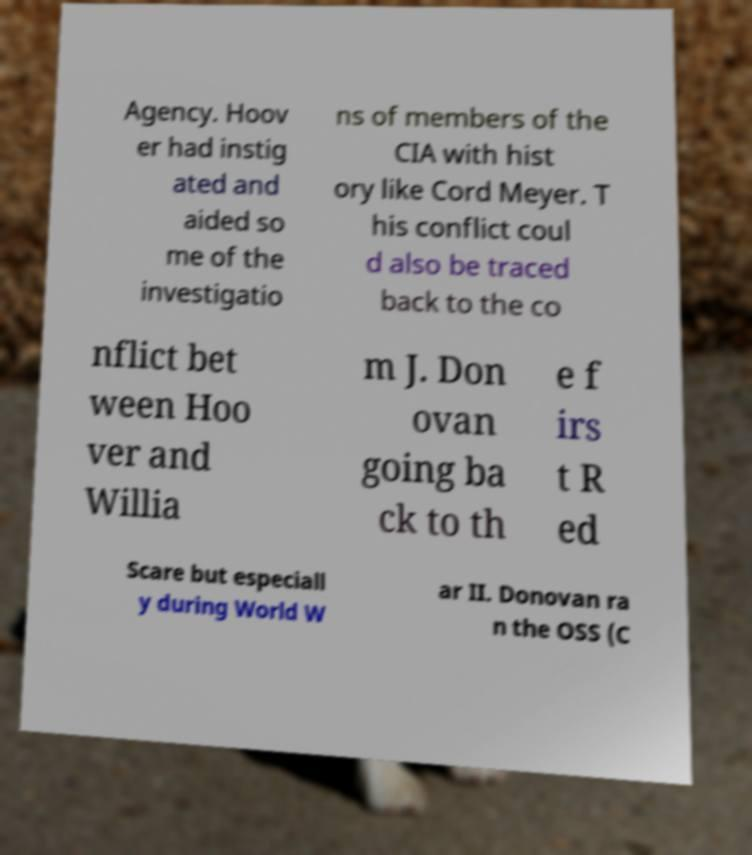Please identify and transcribe the text found in this image. Agency. Hoov er had instig ated and aided so me of the investigatio ns of members of the CIA with hist ory like Cord Meyer. T his conflict coul d also be traced back to the co nflict bet ween Hoo ver and Willia m J. Don ovan going ba ck to th e f irs t R ed Scare but especiall y during World W ar II. Donovan ra n the OSS (C 